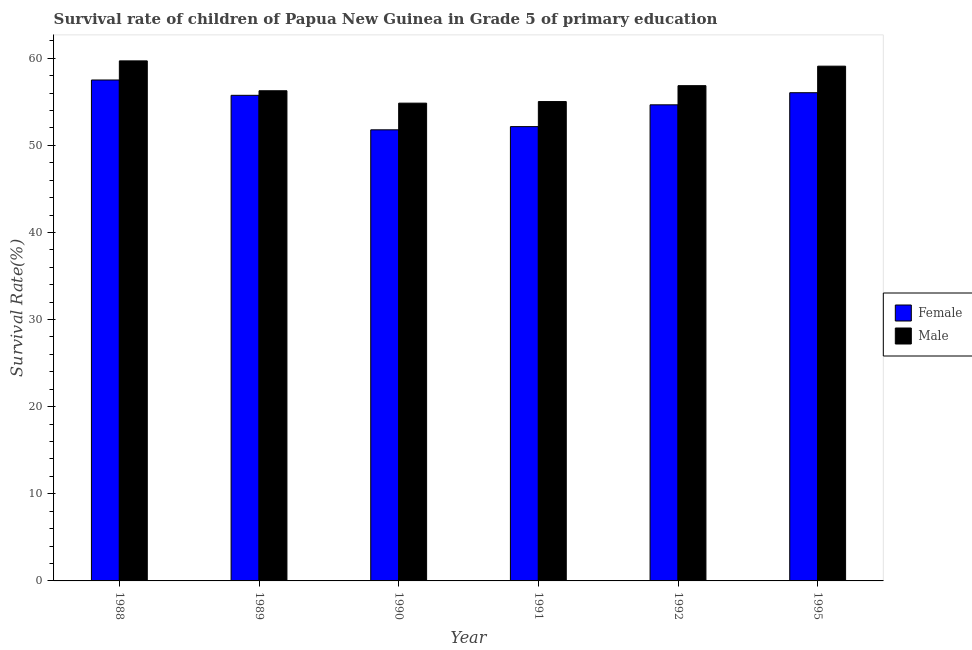How many bars are there on the 2nd tick from the left?
Ensure brevity in your answer.  2. In how many cases, is the number of bars for a given year not equal to the number of legend labels?
Give a very brief answer. 0. What is the survival rate of male students in primary education in 1990?
Make the answer very short. 54.84. Across all years, what is the maximum survival rate of female students in primary education?
Your response must be concise. 57.5. Across all years, what is the minimum survival rate of male students in primary education?
Offer a terse response. 54.84. In which year was the survival rate of female students in primary education maximum?
Give a very brief answer. 1988. In which year was the survival rate of female students in primary education minimum?
Keep it short and to the point. 1990. What is the total survival rate of male students in primary education in the graph?
Ensure brevity in your answer.  341.76. What is the difference between the survival rate of male students in primary education in 1988 and that in 1995?
Your answer should be compact. 0.61. What is the difference between the survival rate of female students in primary education in 1989 and the survival rate of male students in primary education in 1991?
Offer a very short reply. 3.59. What is the average survival rate of male students in primary education per year?
Your response must be concise. 56.96. What is the ratio of the survival rate of female students in primary education in 1989 to that in 1990?
Keep it short and to the point. 1.08. Is the survival rate of female students in primary education in 1988 less than that in 1991?
Offer a very short reply. No. Is the difference between the survival rate of female students in primary education in 1989 and 1995 greater than the difference between the survival rate of male students in primary education in 1989 and 1995?
Offer a terse response. No. What is the difference between the highest and the second highest survival rate of female students in primary education?
Offer a terse response. 1.46. What is the difference between the highest and the lowest survival rate of male students in primary education?
Make the answer very short. 4.85. Is the sum of the survival rate of female students in primary education in 1990 and 1991 greater than the maximum survival rate of male students in primary education across all years?
Provide a short and direct response. Yes. What does the 2nd bar from the left in 1992 represents?
Provide a succinct answer. Male. How many bars are there?
Your answer should be compact. 12. What is the difference between two consecutive major ticks on the Y-axis?
Provide a succinct answer. 10. Does the graph contain any zero values?
Provide a short and direct response. No. Where does the legend appear in the graph?
Give a very brief answer. Center right. How many legend labels are there?
Offer a very short reply. 2. What is the title of the graph?
Offer a terse response. Survival rate of children of Papua New Guinea in Grade 5 of primary education. Does "Education" appear as one of the legend labels in the graph?
Offer a terse response. No. What is the label or title of the X-axis?
Offer a very short reply. Year. What is the label or title of the Y-axis?
Provide a succinct answer. Survival Rate(%). What is the Survival Rate(%) of Female in 1988?
Ensure brevity in your answer.  57.5. What is the Survival Rate(%) of Male in 1988?
Give a very brief answer. 59.69. What is the Survival Rate(%) in Female in 1989?
Ensure brevity in your answer.  55.74. What is the Survival Rate(%) of Male in 1989?
Provide a succinct answer. 56.27. What is the Survival Rate(%) of Female in 1990?
Provide a succinct answer. 51.78. What is the Survival Rate(%) in Male in 1990?
Provide a succinct answer. 54.84. What is the Survival Rate(%) of Female in 1991?
Offer a very short reply. 52.15. What is the Survival Rate(%) in Male in 1991?
Make the answer very short. 55.03. What is the Survival Rate(%) of Female in 1992?
Give a very brief answer. 54.65. What is the Survival Rate(%) of Male in 1992?
Provide a short and direct response. 56.85. What is the Survival Rate(%) of Female in 1995?
Your answer should be compact. 56.04. What is the Survival Rate(%) of Male in 1995?
Give a very brief answer. 59.09. Across all years, what is the maximum Survival Rate(%) in Female?
Provide a short and direct response. 57.5. Across all years, what is the maximum Survival Rate(%) in Male?
Your answer should be very brief. 59.69. Across all years, what is the minimum Survival Rate(%) in Female?
Ensure brevity in your answer.  51.78. Across all years, what is the minimum Survival Rate(%) in Male?
Ensure brevity in your answer.  54.84. What is the total Survival Rate(%) in Female in the graph?
Offer a terse response. 327.86. What is the total Survival Rate(%) of Male in the graph?
Your answer should be compact. 341.76. What is the difference between the Survival Rate(%) in Female in 1988 and that in 1989?
Ensure brevity in your answer.  1.76. What is the difference between the Survival Rate(%) in Male in 1988 and that in 1989?
Give a very brief answer. 3.43. What is the difference between the Survival Rate(%) of Female in 1988 and that in 1990?
Give a very brief answer. 5.72. What is the difference between the Survival Rate(%) in Male in 1988 and that in 1990?
Provide a short and direct response. 4.85. What is the difference between the Survival Rate(%) of Female in 1988 and that in 1991?
Offer a terse response. 5.35. What is the difference between the Survival Rate(%) of Male in 1988 and that in 1991?
Ensure brevity in your answer.  4.67. What is the difference between the Survival Rate(%) of Female in 1988 and that in 1992?
Keep it short and to the point. 2.85. What is the difference between the Survival Rate(%) of Male in 1988 and that in 1992?
Keep it short and to the point. 2.85. What is the difference between the Survival Rate(%) of Female in 1988 and that in 1995?
Give a very brief answer. 1.46. What is the difference between the Survival Rate(%) in Male in 1988 and that in 1995?
Keep it short and to the point. 0.61. What is the difference between the Survival Rate(%) of Female in 1989 and that in 1990?
Provide a succinct answer. 3.96. What is the difference between the Survival Rate(%) of Male in 1989 and that in 1990?
Your answer should be very brief. 1.42. What is the difference between the Survival Rate(%) of Female in 1989 and that in 1991?
Provide a succinct answer. 3.59. What is the difference between the Survival Rate(%) in Male in 1989 and that in 1991?
Offer a terse response. 1.24. What is the difference between the Survival Rate(%) in Female in 1989 and that in 1992?
Offer a very short reply. 1.09. What is the difference between the Survival Rate(%) in Male in 1989 and that in 1992?
Give a very brief answer. -0.58. What is the difference between the Survival Rate(%) of Female in 1989 and that in 1995?
Your answer should be compact. -0.3. What is the difference between the Survival Rate(%) in Male in 1989 and that in 1995?
Provide a succinct answer. -2.82. What is the difference between the Survival Rate(%) of Female in 1990 and that in 1991?
Give a very brief answer. -0.37. What is the difference between the Survival Rate(%) of Male in 1990 and that in 1991?
Provide a short and direct response. -0.18. What is the difference between the Survival Rate(%) of Female in 1990 and that in 1992?
Keep it short and to the point. -2.87. What is the difference between the Survival Rate(%) in Male in 1990 and that in 1992?
Provide a short and direct response. -2.01. What is the difference between the Survival Rate(%) in Female in 1990 and that in 1995?
Your response must be concise. -4.26. What is the difference between the Survival Rate(%) of Male in 1990 and that in 1995?
Give a very brief answer. -4.25. What is the difference between the Survival Rate(%) in Female in 1991 and that in 1992?
Offer a very short reply. -2.5. What is the difference between the Survival Rate(%) in Male in 1991 and that in 1992?
Provide a short and direct response. -1.82. What is the difference between the Survival Rate(%) of Female in 1991 and that in 1995?
Your answer should be compact. -3.89. What is the difference between the Survival Rate(%) of Male in 1991 and that in 1995?
Offer a very short reply. -4.06. What is the difference between the Survival Rate(%) of Female in 1992 and that in 1995?
Ensure brevity in your answer.  -1.39. What is the difference between the Survival Rate(%) of Male in 1992 and that in 1995?
Provide a short and direct response. -2.24. What is the difference between the Survival Rate(%) in Female in 1988 and the Survival Rate(%) in Male in 1989?
Provide a succinct answer. 1.23. What is the difference between the Survival Rate(%) of Female in 1988 and the Survival Rate(%) of Male in 1990?
Your answer should be compact. 2.66. What is the difference between the Survival Rate(%) of Female in 1988 and the Survival Rate(%) of Male in 1991?
Offer a very short reply. 2.47. What is the difference between the Survival Rate(%) of Female in 1988 and the Survival Rate(%) of Male in 1992?
Offer a terse response. 0.65. What is the difference between the Survival Rate(%) of Female in 1988 and the Survival Rate(%) of Male in 1995?
Your answer should be compact. -1.59. What is the difference between the Survival Rate(%) of Female in 1989 and the Survival Rate(%) of Male in 1990?
Offer a terse response. 0.9. What is the difference between the Survival Rate(%) in Female in 1989 and the Survival Rate(%) in Male in 1991?
Give a very brief answer. 0.72. What is the difference between the Survival Rate(%) in Female in 1989 and the Survival Rate(%) in Male in 1992?
Your answer should be very brief. -1.11. What is the difference between the Survival Rate(%) of Female in 1989 and the Survival Rate(%) of Male in 1995?
Provide a short and direct response. -3.35. What is the difference between the Survival Rate(%) of Female in 1990 and the Survival Rate(%) of Male in 1991?
Offer a very short reply. -3.24. What is the difference between the Survival Rate(%) of Female in 1990 and the Survival Rate(%) of Male in 1992?
Keep it short and to the point. -5.07. What is the difference between the Survival Rate(%) of Female in 1990 and the Survival Rate(%) of Male in 1995?
Offer a very short reply. -7.31. What is the difference between the Survival Rate(%) in Female in 1991 and the Survival Rate(%) in Male in 1992?
Your answer should be very brief. -4.7. What is the difference between the Survival Rate(%) of Female in 1991 and the Survival Rate(%) of Male in 1995?
Provide a short and direct response. -6.94. What is the difference between the Survival Rate(%) of Female in 1992 and the Survival Rate(%) of Male in 1995?
Offer a terse response. -4.44. What is the average Survival Rate(%) of Female per year?
Offer a terse response. 54.64. What is the average Survival Rate(%) of Male per year?
Offer a terse response. 56.96. In the year 1988, what is the difference between the Survival Rate(%) in Female and Survival Rate(%) in Male?
Offer a very short reply. -2.19. In the year 1989, what is the difference between the Survival Rate(%) of Female and Survival Rate(%) of Male?
Your answer should be very brief. -0.52. In the year 1990, what is the difference between the Survival Rate(%) in Female and Survival Rate(%) in Male?
Keep it short and to the point. -3.06. In the year 1991, what is the difference between the Survival Rate(%) of Female and Survival Rate(%) of Male?
Your answer should be compact. -2.88. In the year 1992, what is the difference between the Survival Rate(%) in Female and Survival Rate(%) in Male?
Your answer should be compact. -2.2. In the year 1995, what is the difference between the Survival Rate(%) of Female and Survival Rate(%) of Male?
Your answer should be compact. -3.05. What is the ratio of the Survival Rate(%) in Female in 1988 to that in 1989?
Your answer should be compact. 1.03. What is the ratio of the Survival Rate(%) in Male in 1988 to that in 1989?
Your answer should be very brief. 1.06. What is the ratio of the Survival Rate(%) of Female in 1988 to that in 1990?
Provide a short and direct response. 1.11. What is the ratio of the Survival Rate(%) in Male in 1988 to that in 1990?
Your answer should be compact. 1.09. What is the ratio of the Survival Rate(%) in Female in 1988 to that in 1991?
Provide a succinct answer. 1.1. What is the ratio of the Survival Rate(%) in Male in 1988 to that in 1991?
Your answer should be very brief. 1.08. What is the ratio of the Survival Rate(%) of Female in 1988 to that in 1992?
Offer a very short reply. 1.05. What is the ratio of the Survival Rate(%) of Male in 1988 to that in 1992?
Your answer should be compact. 1.05. What is the ratio of the Survival Rate(%) of Male in 1988 to that in 1995?
Offer a very short reply. 1.01. What is the ratio of the Survival Rate(%) of Female in 1989 to that in 1990?
Offer a terse response. 1.08. What is the ratio of the Survival Rate(%) of Male in 1989 to that in 1990?
Ensure brevity in your answer.  1.03. What is the ratio of the Survival Rate(%) of Female in 1989 to that in 1991?
Keep it short and to the point. 1.07. What is the ratio of the Survival Rate(%) of Male in 1989 to that in 1991?
Your response must be concise. 1.02. What is the ratio of the Survival Rate(%) in Female in 1989 to that in 1992?
Keep it short and to the point. 1.02. What is the ratio of the Survival Rate(%) in Male in 1989 to that in 1995?
Make the answer very short. 0.95. What is the ratio of the Survival Rate(%) of Male in 1990 to that in 1991?
Provide a succinct answer. 1. What is the ratio of the Survival Rate(%) of Female in 1990 to that in 1992?
Provide a succinct answer. 0.95. What is the ratio of the Survival Rate(%) of Male in 1990 to that in 1992?
Your response must be concise. 0.96. What is the ratio of the Survival Rate(%) of Female in 1990 to that in 1995?
Offer a terse response. 0.92. What is the ratio of the Survival Rate(%) of Male in 1990 to that in 1995?
Offer a very short reply. 0.93. What is the ratio of the Survival Rate(%) in Female in 1991 to that in 1992?
Your answer should be compact. 0.95. What is the ratio of the Survival Rate(%) in Male in 1991 to that in 1992?
Provide a succinct answer. 0.97. What is the ratio of the Survival Rate(%) in Female in 1991 to that in 1995?
Make the answer very short. 0.93. What is the ratio of the Survival Rate(%) of Male in 1991 to that in 1995?
Your answer should be very brief. 0.93. What is the ratio of the Survival Rate(%) in Female in 1992 to that in 1995?
Offer a terse response. 0.98. What is the ratio of the Survival Rate(%) of Male in 1992 to that in 1995?
Your answer should be compact. 0.96. What is the difference between the highest and the second highest Survival Rate(%) of Female?
Give a very brief answer. 1.46. What is the difference between the highest and the second highest Survival Rate(%) of Male?
Offer a very short reply. 0.61. What is the difference between the highest and the lowest Survival Rate(%) of Female?
Give a very brief answer. 5.72. What is the difference between the highest and the lowest Survival Rate(%) in Male?
Ensure brevity in your answer.  4.85. 